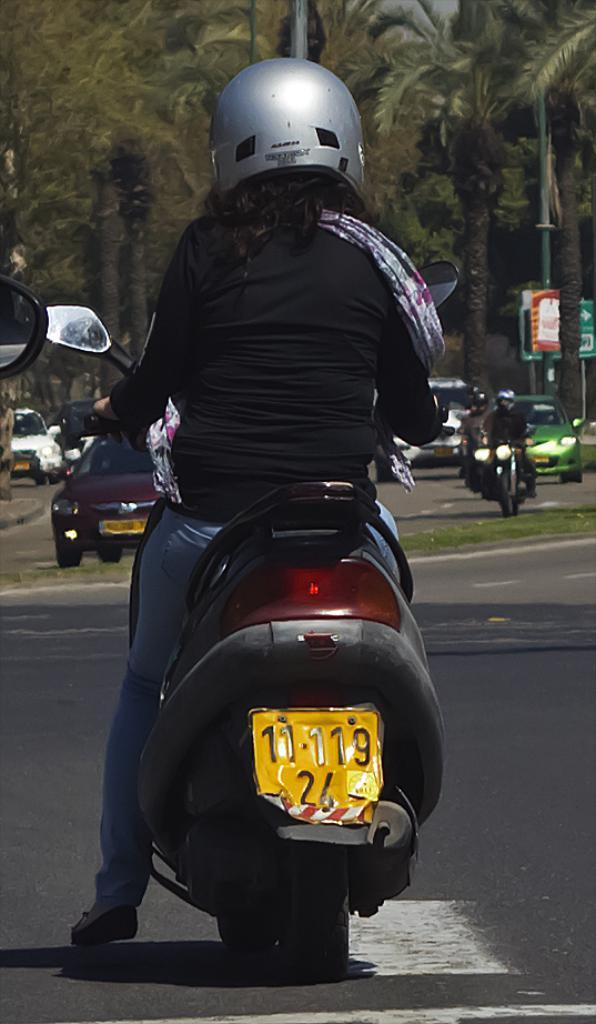What is happening in the foreground of the image? There is a person sitting on a vehicle in the foreground. What can be seen in the background of the image? There are vehicles on the road and trees visible in the background. What is the opinion of the goat about the vehicles on the road? There is no goat present in the image, so it is not possible to determine its opinion about the vehicles on the road. 